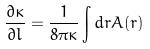<formula> <loc_0><loc_0><loc_500><loc_500>\frac { \partial \kappa } { \partial l } = \frac { 1 } { 8 \pi \kappa } \int d { r } A ( r )</formula> 